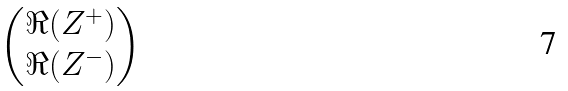<formula> <loc_0><loc_0><loc_500><loc_500>\begin{pmatrix} \Re ( Z ^ { + } ) \\ \Re ( Z ^ { - } ) \end{pmatrix}</formula> 